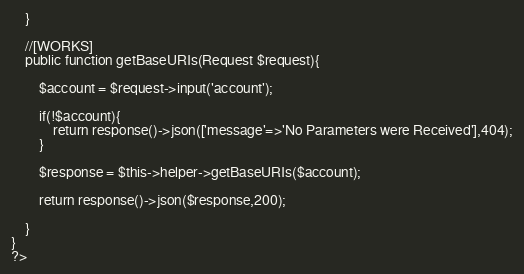Convert code to text. <code><loc_0><loc_0><loc_500><loc_500><_PHP_>    }

    //[WORKS]
    public function getBaseURIs(Request $request){

        $account = $request->input('account');

        if(!$account){
            return response()->json(['message'=>'No Parameters were Received'],404);
        }

        $response = $this->helper->getBaseURIs($account);

        return response()->json($response,200);

    }
}
?>
</code> 